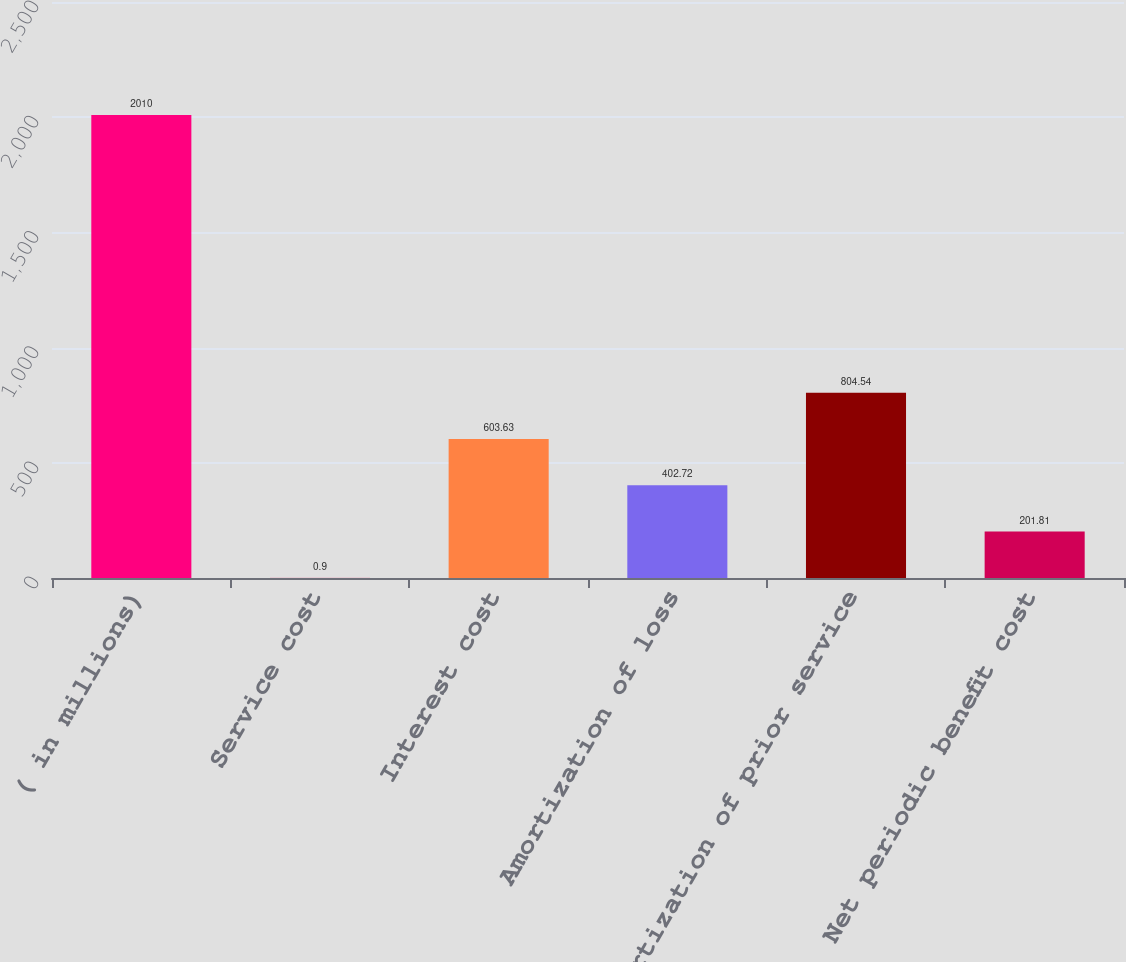Convert chart. <chart><loc_0><loc_0><loc_500><loc_500><bar_chart><fcel>( in millions)<fcel>Service cost<fcel>Interest cost<fcel>Amortization of loss<fcel>Amortization of prior service<fcel>Net periodic benefit cost<nl><fcel>2010<fcel>0.9<fcel>603.63<fcel>402.72<fcel>804.54<fcel>201.81<nl></chart> 